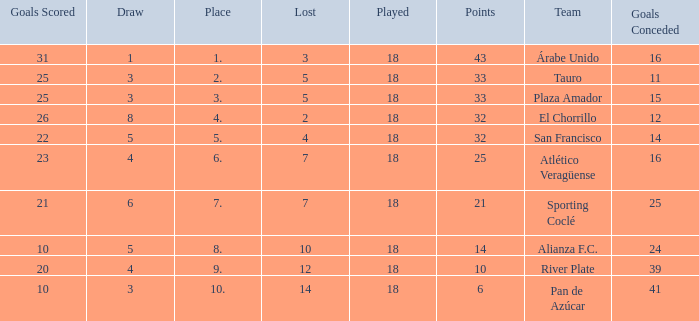How many points did the team have that conceded 41 goals and finish in a place larger than 10? 0.0. 